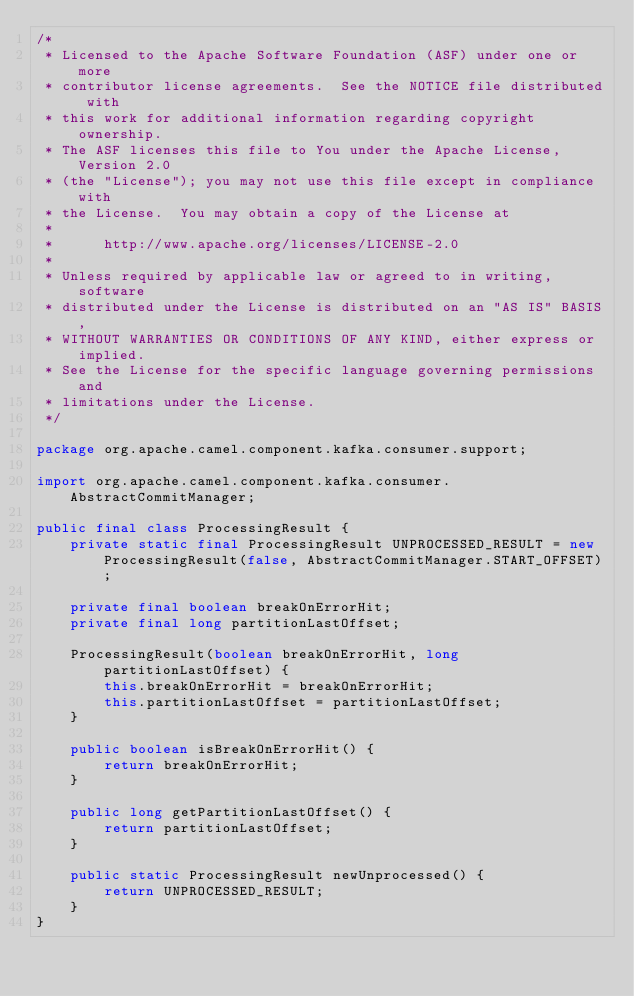Convert code to text. <code><loc_0><loc_0><loc_500><loc_500><_Java_>/*
 * Licensed to the Apache Software Foundation (ASF) under one or more
 * contributor license agreements.  See the NOTICE file distributed with
 * this work for additional information regarding copyright ownership.
 * The ASF licenses this file to You under the Apache License, Version 2.0
 * (the "License"); you may not use this file except in compliance with
 * the License.  You may obtain a copy of the License at
 *
 *      http://www.apache.org/licenses/LICENSE-2.0
 *
 * Unless required by applicable law or agreed to in writing, software
 * distributed under the License is distributed on an "AS IS" BASIS,
 * WITHOUT WARRANTIES OR CONDITIONS OF ANY KIND, either express or implied.
 * See the License for the specific language governing permissions and
 * limitations under the License.
 */

package org.apache.camel.component.kafka.consumer.support;

import org.apache.camel.component.kafka.consumer.AbstractCommitManager;

public final class ProcessingResult {
    private static final ProcessingResult UNPROCESSED_RESULT = new ProcessingResult(false, AbstractCommitManager.START_OFFSET);

    private final boolean breakOnErrorHit;
    private final long partitionLastOffset;

    ProcessingResult(boolean breakOnErrorHit, long partitionLastOffset) {
        this.breakOnErrorHit = breakOnErrorHit;
        this.partitionLastOffset = partitionLastOffset;
    }

    public boolean isBreakOnErrorHit() {
        return breakOnErrorHit;
    }

    public long getPartitionLastOffset() {
        return partitionLastOffset;
    }

    public static ProcessingResult newUnprocessed() {
        return UNPROCESSED_RESULT;
    }
}
</code> 